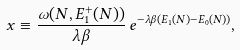<formula> <loc_0><loc_0><loc_500><loc_500>x \equiv \frac { \omega ( N , E _ { 1 } ^ { + } ( N ) ) } { \lambda \beta } \, e ^ { - \lambda \beta ( E _ { 1 } ( N ) - E _ { 0 } ( N ) ) } ,</formula> 